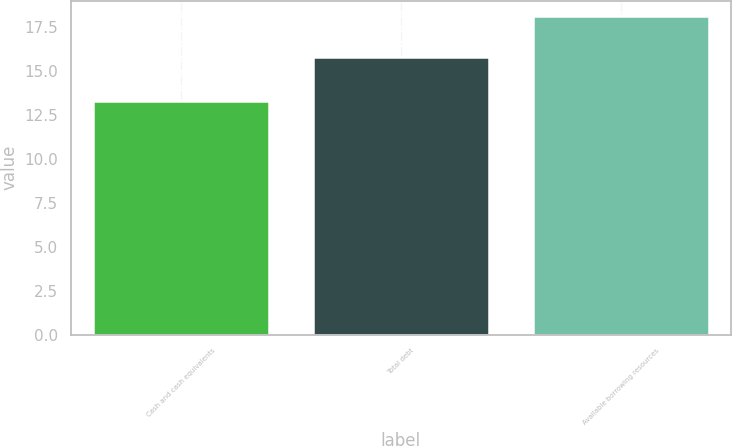Convert chart. <chart><loc_0><loc_0><loc_500><loc_500><bar_chart><fcel>Cash and cash equivalents<fcel>Total debt<fcel>Available borrowing resources<nl><fcel>13.3<fcel>15.8<fcel>18.1<nl></chart> 